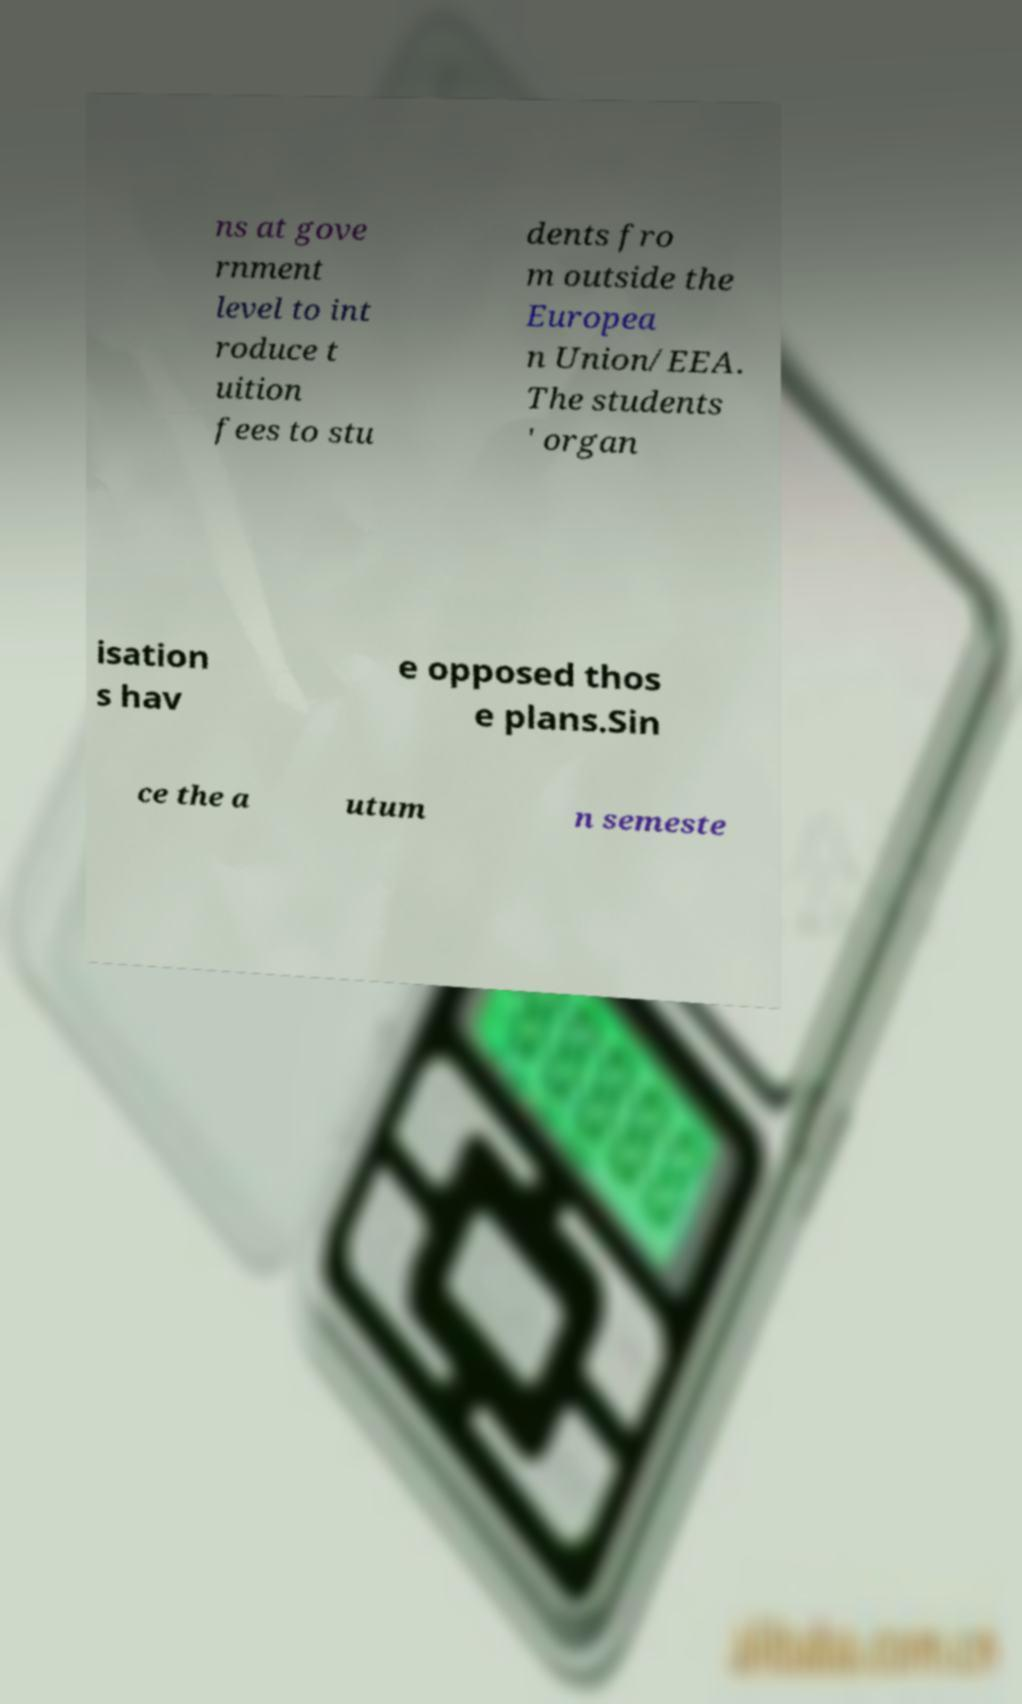Could you assist in decoding the text presented in this image and type it out clearly? ns at gove rnment level to int roduce t uition fees to stu dents fro m outside the Europea n Union/EEA. The students ' organ isation s hav e opposed thos e plans.Sin ce the a utum n semeste 